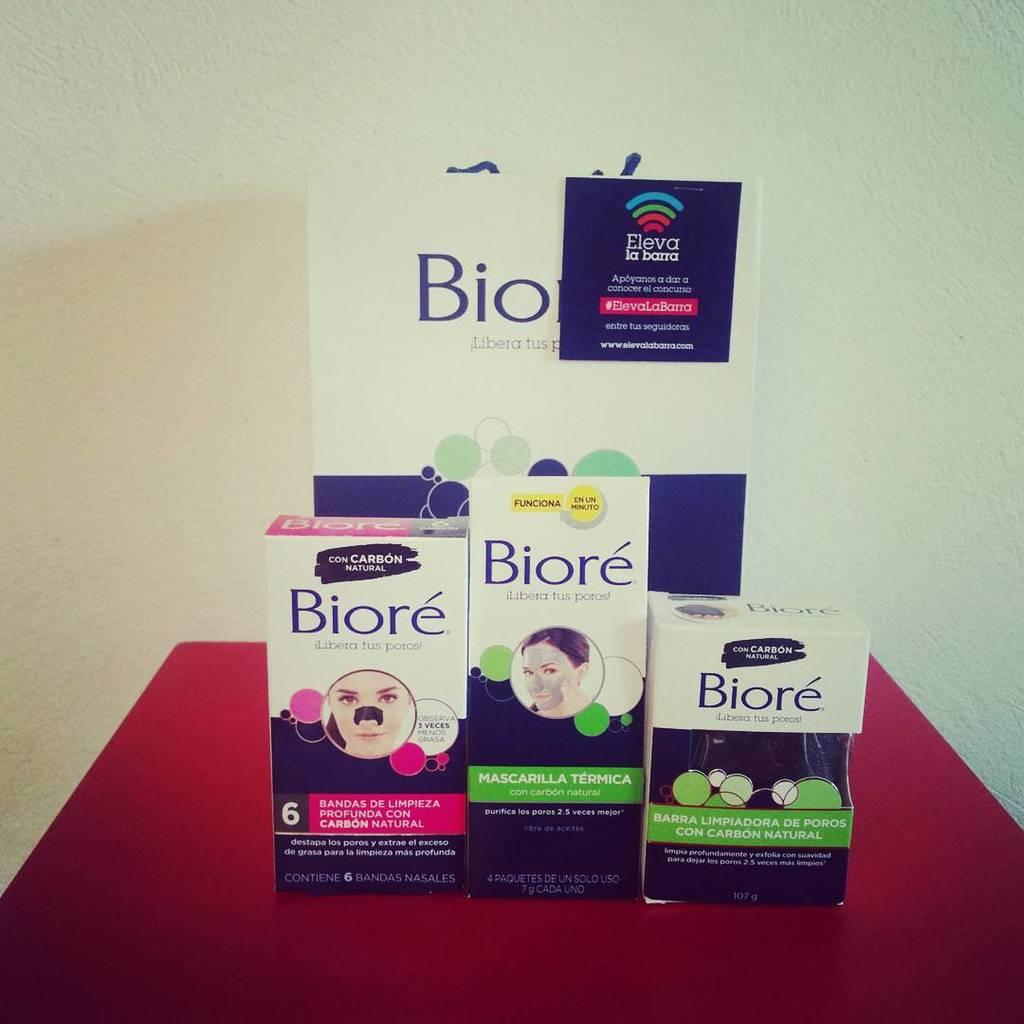What can be seen on the surface in the image? There are objects on the surface in the image. What is written or depicted on the objects? There is text on the objects in the image. What type of structure is visible in the image? There is a wall in the image. What is the rate of the statement made by the middle object in the image? There is no statement or rate mentioned in the image, as it only contains objects with text on them and a wall. 